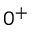Convert formula to latex. <formula><loc_0><loc_0><loc_500><loc_500>0 ^ { + }</formula> 